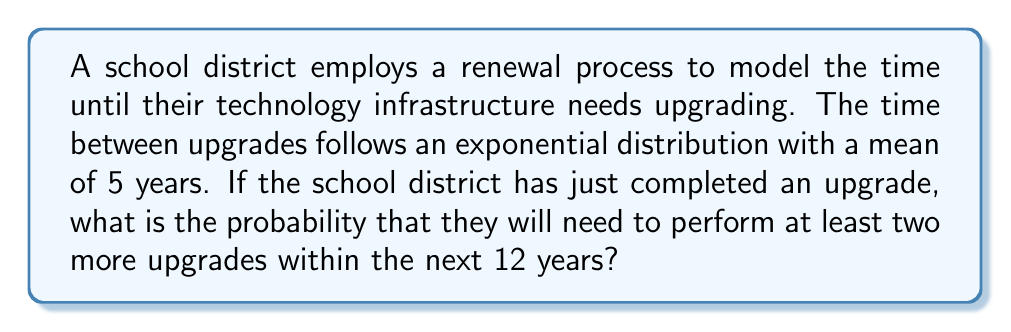Show me your answer to this math problem. Let's approach this step-by-step:

1) First, we need to understand that we're dealing with a Poisson process, as the inter-arrival times (time between upgrades) are exponentially distributed.

2) The rate parameter λ for the exponential distribution is the inverse of the mean:
   $$ λ = \frac{1}{5} = 0.2 \text{ upgrades/year} $$

3) In a Poisson process, the number of events in a fixed time interval follows a Poisson distribution. The mean of this Poisson distribution for a time interval t is λt.

4) In this case, we're looking at a 12-year interval, so the mean number of upgrades in 12 years is:
   $$ μ = λt = 0.2 * 12 = 2.4 \text{ upgrades} $$

5) We want the probability of at least two upgrades in 12 years. This is equivalent to 1 minus the probability of fewer than two upgrades:
   $$ P(\text{at least 2 upgrades}) = 1 - P(0 \text{ upgrades}) - P(1 \text{ upgrade}) $$

6) Using the Poisson probability mass function:
   $$ P(X = k) = \frac{e^{-μ}μ^k}{k!} $$

   Where X is the number of upgrades and k is the specific number we're calculating for.

7) Calculating:
   $$ P(0 \text{ upgrades}) = \frac{e^{-2.4}2.4^0}{0!} = e^{-2.4} ≈ 0.0907 $$
   $$ P(1 \text{ upgrade}) = \frac{e^{-2.4}2.4^1}{1!} = 2.4e^{-2.4} ≈ 0.2177 $$

8) Therefore:
   $$ P(\text{at least 2 upgrades}) = 1 - 0.0907 - 0.2177 = 0.6916 $$
Answer: 0.6916 